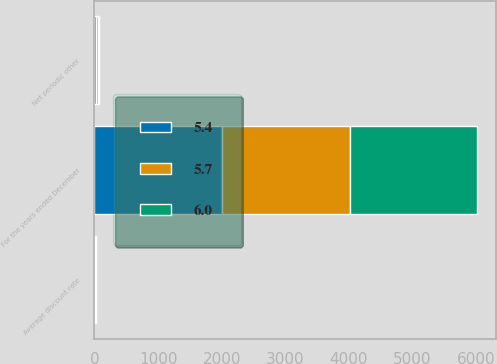Convert chart to OTSL. <chart><loc_0><loc_0><loc_500><loc_500><stacked_bar_chart><ecel><fcel>For the years ended December<fcel>Net periodic other<fcel>Average discount rate<nl><fcel>5.7<fcel>2006<fcel>28.7<fcel>5.4<nl><fcel>6<fcel>2005<fcel>24.6<fcel>5.7<nl><fcel>5.4<fcel>2004<fcel>24.3<fcel>6<nl></chart> 